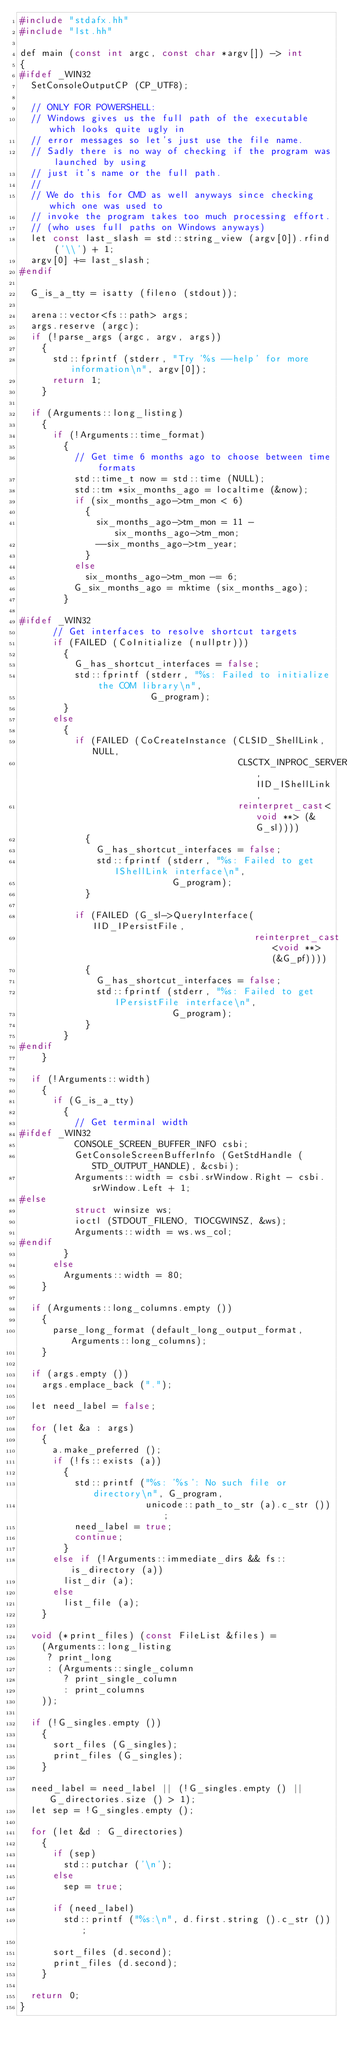Convert code to text. <code><loc_0><loc_0><loc_500><loc_500><_C++_>#include "stdafx.hh"
#include "lst.hh"

def main (const int argc, const char *argv[]) -> int
{
#ifdef _WIN32
  SetConsoleOutputCP (CP_UTF8);

  // ONLY FOR POWERSHELL:
  // Windows gives us the full path of the executable which looks quite ugly in
  // error messages so let's just use the file name.
  // Sadly there is no way of checking if the program was launched by using
  // just it's name or the full path.
  //
  // We do this for CMD as well anyways since checking which one was used to
  // invoke the program takes too much processing effort.
  // (who uses full paths on Windows anyways)
  let const last_slash = std::string_view (argv[0]).rfind ('\\') + 1;
  argv[0] += last_slash;
#endif

  G_is_a_tty = isatty (fileno (stdout));

  arena::vector<fs::path> args;
  args.reserve (argc);
  if (!parse_args (argc, argv, args))
    {
      std::fprintf (stderr, "Try '%s --help' for more information\n", argv[0]);
      return 1;
    }

  if (Arguments::long_listing)
    {
      if (!Arguments::time_format)
        {
          // Get time 6 months ago to choose between time formats
          std::time_t now = std::time (NULL);
          std::tm *six_months_ago = localtime (&now);
          if (six_months_ago->tm_mon < 6)
            {
              six_months_ago->tm_mon = 11 - six_months_ago->tm_mon;
              --six_months_ago->tm_year;
            }
          else
            six_months_ago->tm_mon -= 6;
          G_six_months_ago = mktime (six_months_ago);
        }

#ifdef _WIN32
      // Get interfaces to resolve shortcut targets
      if (FAILED (CoInitialize (nullptr)))
        {
          G_has_shortcut_interfaces = false;
          std::fprintf (stderr, "%s: Failed to initialize the COM library\n",
                        G_program);
        }
      else
        {
          if (FAILED (CoCreateInstance (CLSID_ShellLink, NULL,
                                        CLSCTX_INPROC_SERVER, IID_IShellLink,
                                        reinterpret_cast<void **> (&G_sl))))
            {
              G_has_shortcut_interfaces = false;
              std::fprintf (stderr, "%s: Failed to get IShellLink interface\n",
                            G_program);
            }

          if (FAILED (G_sl->QueryInterface(IID_IPersistFile,
                                           reinterpret_cast<void **> (&G_pf))))
            {
              G_has_shortcut_interfaces = false;
              std::fprintf (stderr, "%s: Failed to get IPersistFile interface\n",
                            G_program);
            }
        }
#endif
    }

  if (!Arguments::width)
    {
      if (G_is_a_tty)
        {
          // Get terminal width
#ifdef _WIN32
          CONSOLE_SCREEN_BUFFER_INFO csbi;
          GetConsoleScreenBufferInfo (GetStdHandle (STD_OUTPUT_HANDLE), &csbi);
          Arguments::width = csbi.srWindow.Right - csbi.srWindow.Left + 1;
#else
          struct winsize ws;
          ioctl (STDOUT_FILENO, TIOCGWINSZ, &ws);
          Arguments::width = ws.ws_col;
#endif
        }
      else
        Arguments::width = 80;
    }

  if (Arguments::long_columns.empty ())
    {
      parse_long_format (default_long_output_format, Arguments::long_columns);
    }

  if (args.empty ())
    args.emplace_back (".");

  let need_label = false;

  for (let &a : args)
    {
      a.make_preferred ();
      if (!fs::exists (a))
        {
          std::printf ("%s: '%s': No such file or directory\n", G_program,
                       unicode::path_to_str (a).c_str ());
          need_label = true;
          continue;
        }
      else if (!Arguments::immediate_dirs && fs::is_directory (a))
        list_dir (a);
      else
        list_file (a);
    }

  void (*print_files) (const FileList &files) =
    (Arguments::long_listing
     ? print_long
     : (Arguments::single_column
        ? print_single_column
        : print_columns
    ));

  if (!G_singles.empty ())
    {
      sort_files (G_singles);
      print_files (G_singles);
    }

  need_label = need_label || (!G_singles.empty () || G_directories.size () > 1);
  let sep = !G_singles.empty ();

  for (let &d : G_directories)
    {
      if (sep)
        std::putchar ('\n');
      else
        sep = true;

      if (need_label)
        std::printf ("%s:\n", d.first.string ().c_str ());

      sort_files (d.second);
      print_files (d.second);
    }

  return 0;
}
</code> 